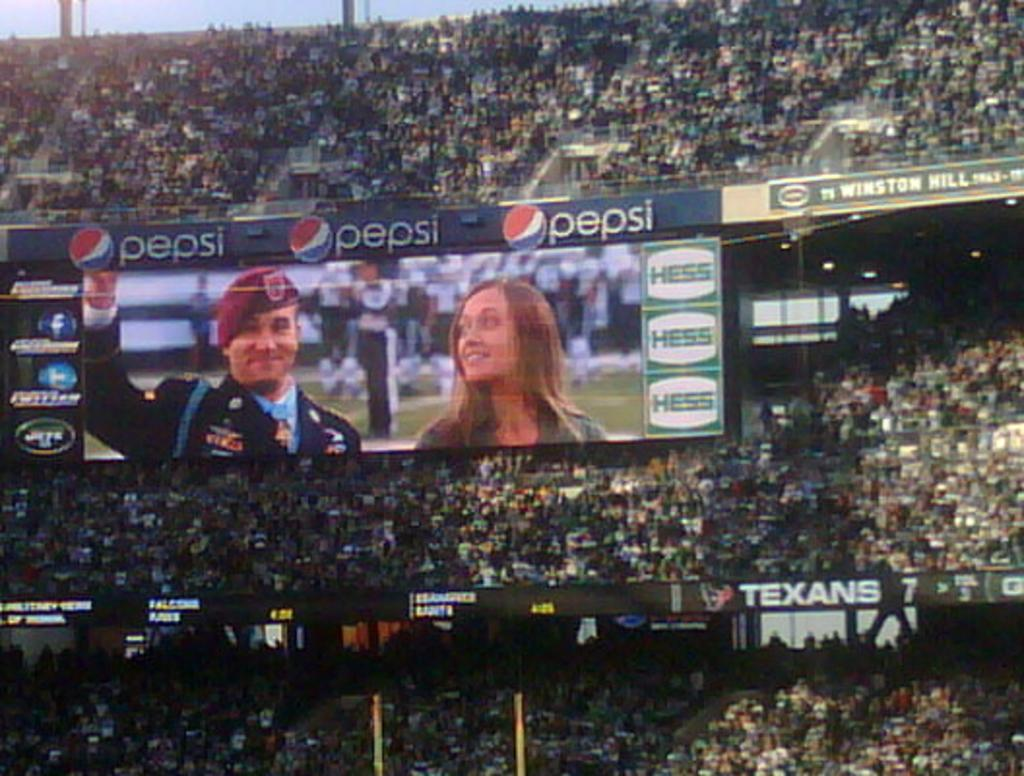<image>
Write a terse but informative summary of the picture. A crowd sees a military man on the screen and that Pepsi is a sponsor of this. 